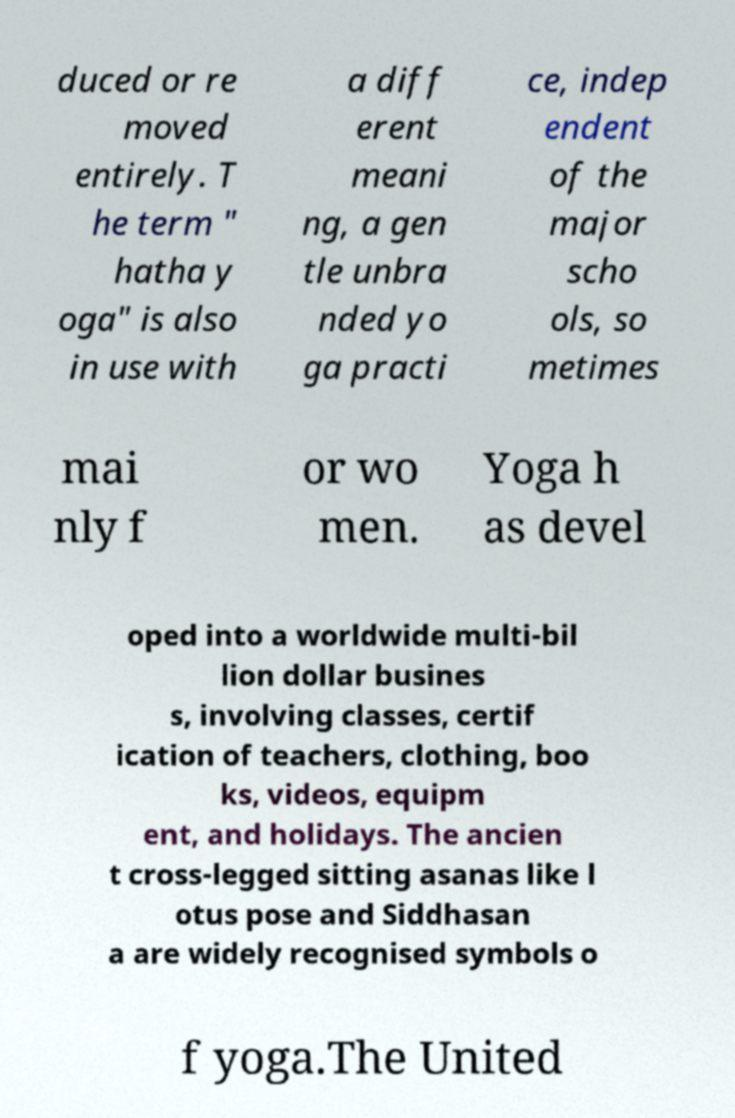There's text embedded in this image that I need extracted. Can you transcribe it verbatim? duced or re moved entirely. T he term " hatha y oga" is also in use with a diff erent meani ng, a gen tle unbra nded yo ga practi ce, indep endent of the major scho ols, so metimes mai nly f or wo men. Yoga h as devel oped into a worldwide multi-bil lion dollar busines s, involving classes, certif ication of teachers, clothing, boo ks, videos, equipm ent, and holidays. The ancien t cross-legged sitting asanas like l otus pose and Siddhasan a are widely recognised symbols o f yoga.The United 